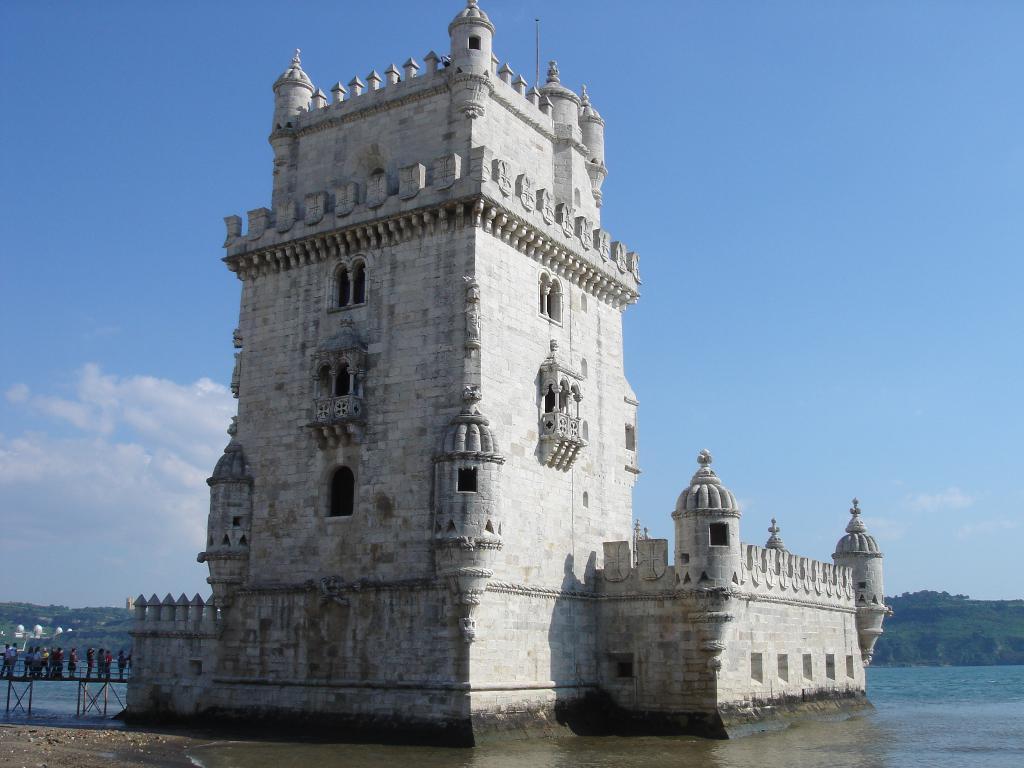Please provide a concise description of this image. In this image we can see a building, few people standing on the bridge beside the building, in the background there is water, mountains and the sky with clouds. 